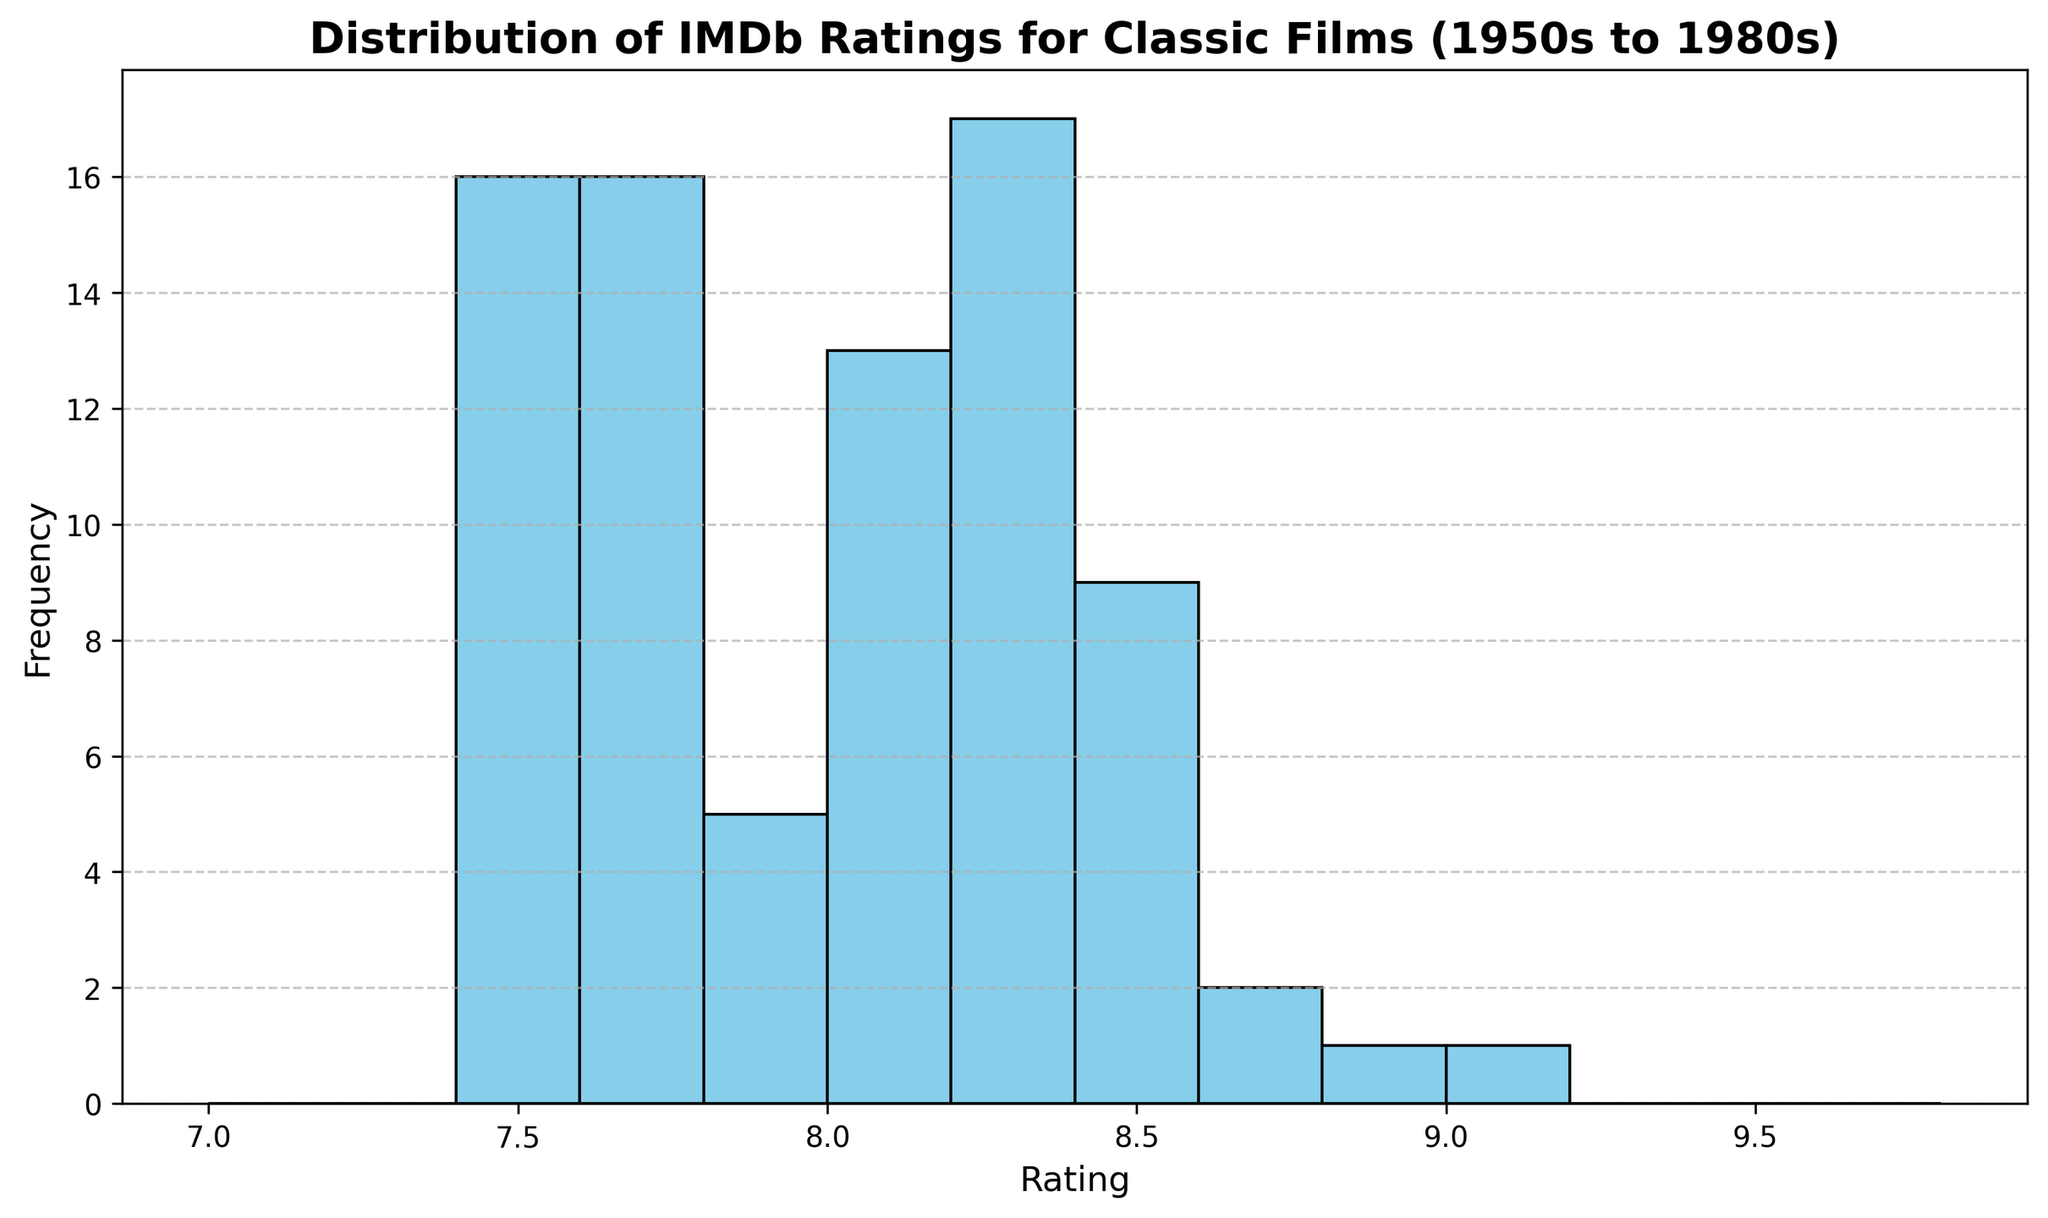What is the most common rating range for these classic films? By observing the tallest bar in the histogram, we can determine the most frequent rating range, which appears to be between 8.2 and 8.4.
Answer: 8.2-8.4 How many rating ranges have a frequency of more than 10? Count the bars in the histogram where the height exceeds the 10 mark on the y-axis. There are two such ranges, from 8.2-8.4 and 7.6-7.8.
Answer: 2 Which rating range has the least number of films? Identify the shortest bar in the histogram, which represents the rating range with the least number of films. The range from 9.0 to 9.2 has the least frequency.
Answer: 9.0-9.2 Are there more films with ratings above 8.5 or below 8.0? Sum the frequencies of all bars corresponding to ratings above 8.5 and compare it to the sum of frequencies for ratings below 8.0. There are fewer films with ratings above 8.5.
Answer: Below 8.0 What is the total number of films rated between 8.0 and 8.6? Sum the frequencies of all bars representing the rating ranges from 8.0 to 8.6. These ranges are 8.0-8.2, 8.2-8.4, and 8.4-8.6.
Answer: 31 What rating range is represented by the bar with a height closest to 8? Find the bar whose height is nearest to 8 on the y-axis. This is the range 8.2-8.4.
Answer: 8.2-8.4 How does the number of films with ratings from 7.8 to 8.0 compare to those from 8.8 to 9.0? Compare the heights of the bars corresponding to these rating ranges. The range from 7.8 to 8.0 has a higher frequency than 8.8 to 9.0.
Answer: More in 7.8-8.0 Is there a rating range that does not have any films? Look for any bins in the histogram with a height of zero; all bins have some films so there are no empty ranges.
Answer: No 